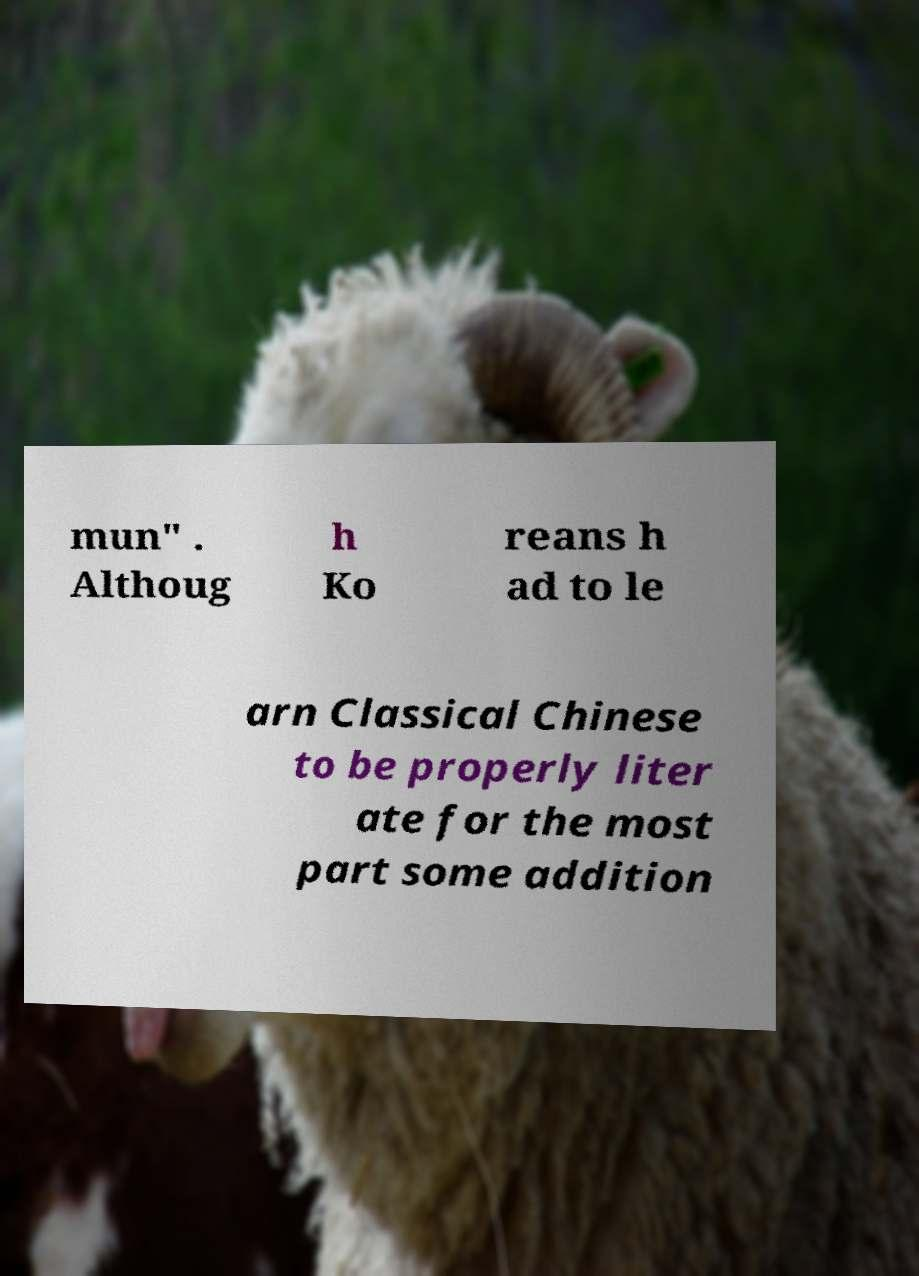Please identify and transcribe the text found in this image. mun" . Althoug h Ko reans h ad to le arn Classical Chinese to be properly liter ate for the most part some addition 